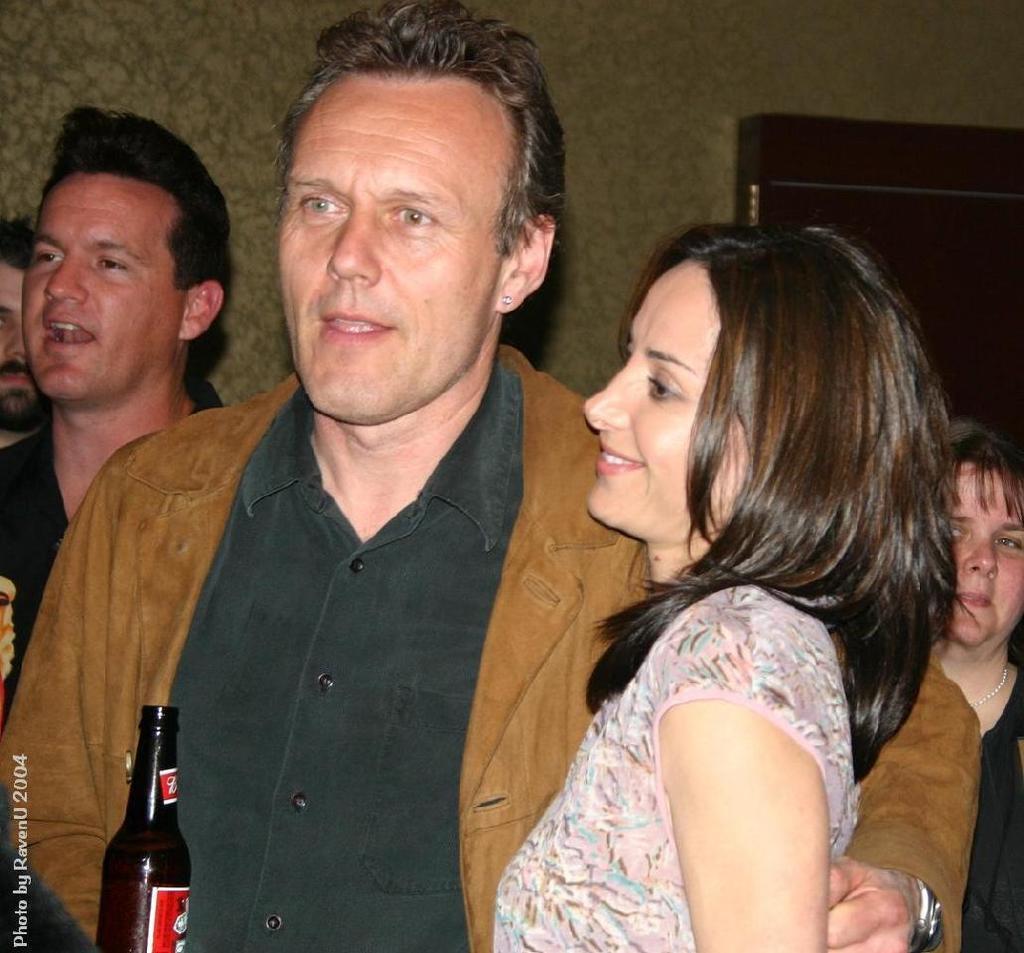In one or two sentences, can you explain what this image depicts? In the image we can see there are people who are standing and there is wine bottle in front. 